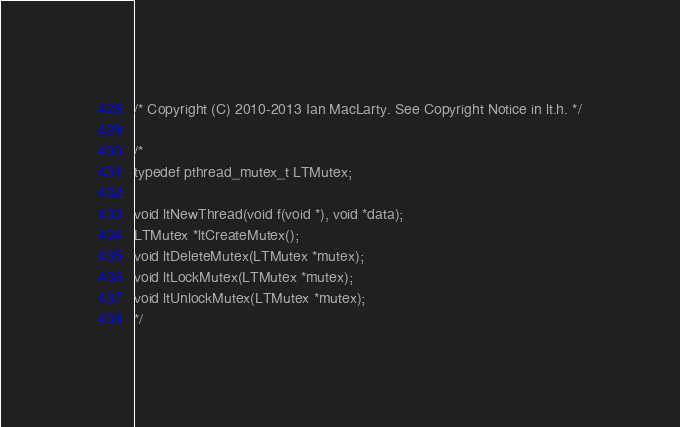Convert code to text. <code><loc_0><loc_0><loc_500><loc_500><_C_>/* Copyright (C) 2010-2013 Ian MacLarty. See Copyright Notice in lt.h. */

/*
typedef pthread_mutex_t LTMutex;

void ltNewThread(void f(void *), void *data);
LTMutex *ltCreateMutex();
void ltDeleteMutex(LTMutex *mutex);
void ltLockMutex(LTMutex *mutex);
void ltUnlockMutex(LTMutex *mutex);
*/
</code> 